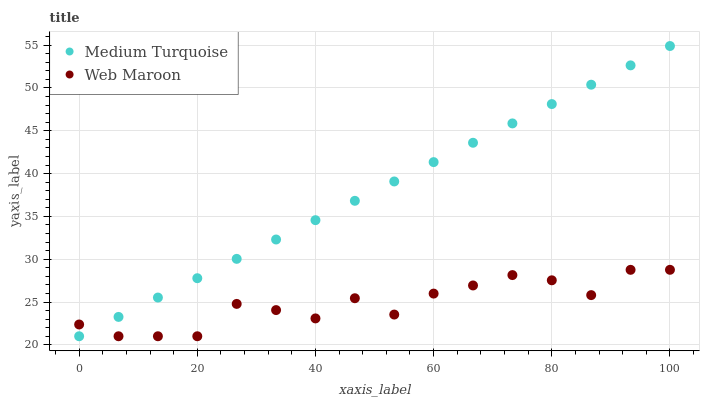Does Web Maroon have the minimum area under the curve?
Answer yes or no. Yes. Does Medium Turquoise have the maximum area under the curve?
Answer yes or no. Yes. Does Medium Turquoise have the minimum area under the curve?
Answer yes or no. No. Is Medium Turquoise the smoothest?
Answer yes or no. Yes. Is Web Maroon the roughest?
Answer yes or no. Yes. Is Medium Turquoise the roughest?
Answer yes or no. No. Does Web Maroon have the lowest value?
Answer yes or no. Yes. Does Medium Turquoise have the highest value?
Answer yes or no. Yes. Does Web Maroon intersect Medium Turquoise?
Answer yes or no. Yes. Is Web Maroon less than Medium Turquoise?
Answer yes or no. No. Is Web Maroon greater than Medium Turquoise?
Answer yes or no. No. 